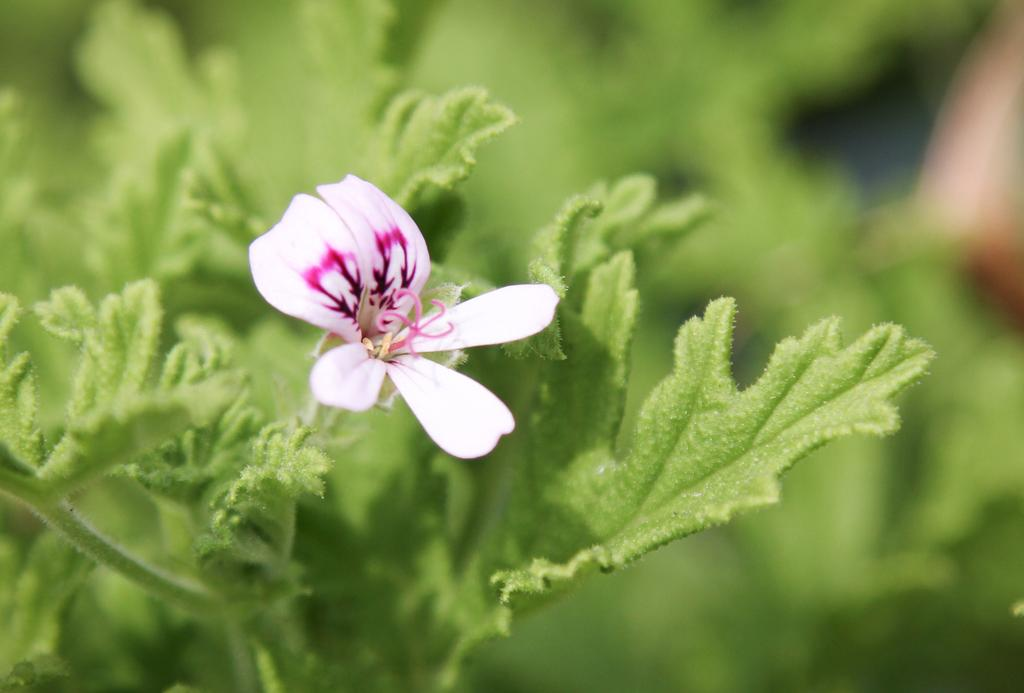What is the main subject of the image? There is a flower in the image. What else can be seen in the image besides the flower? There are leaves in the image. How would you describe the background of the image? The background of the image is blurry. Can you see an airplane flying in the background of the image? No, there is no airplane visible in the image. 